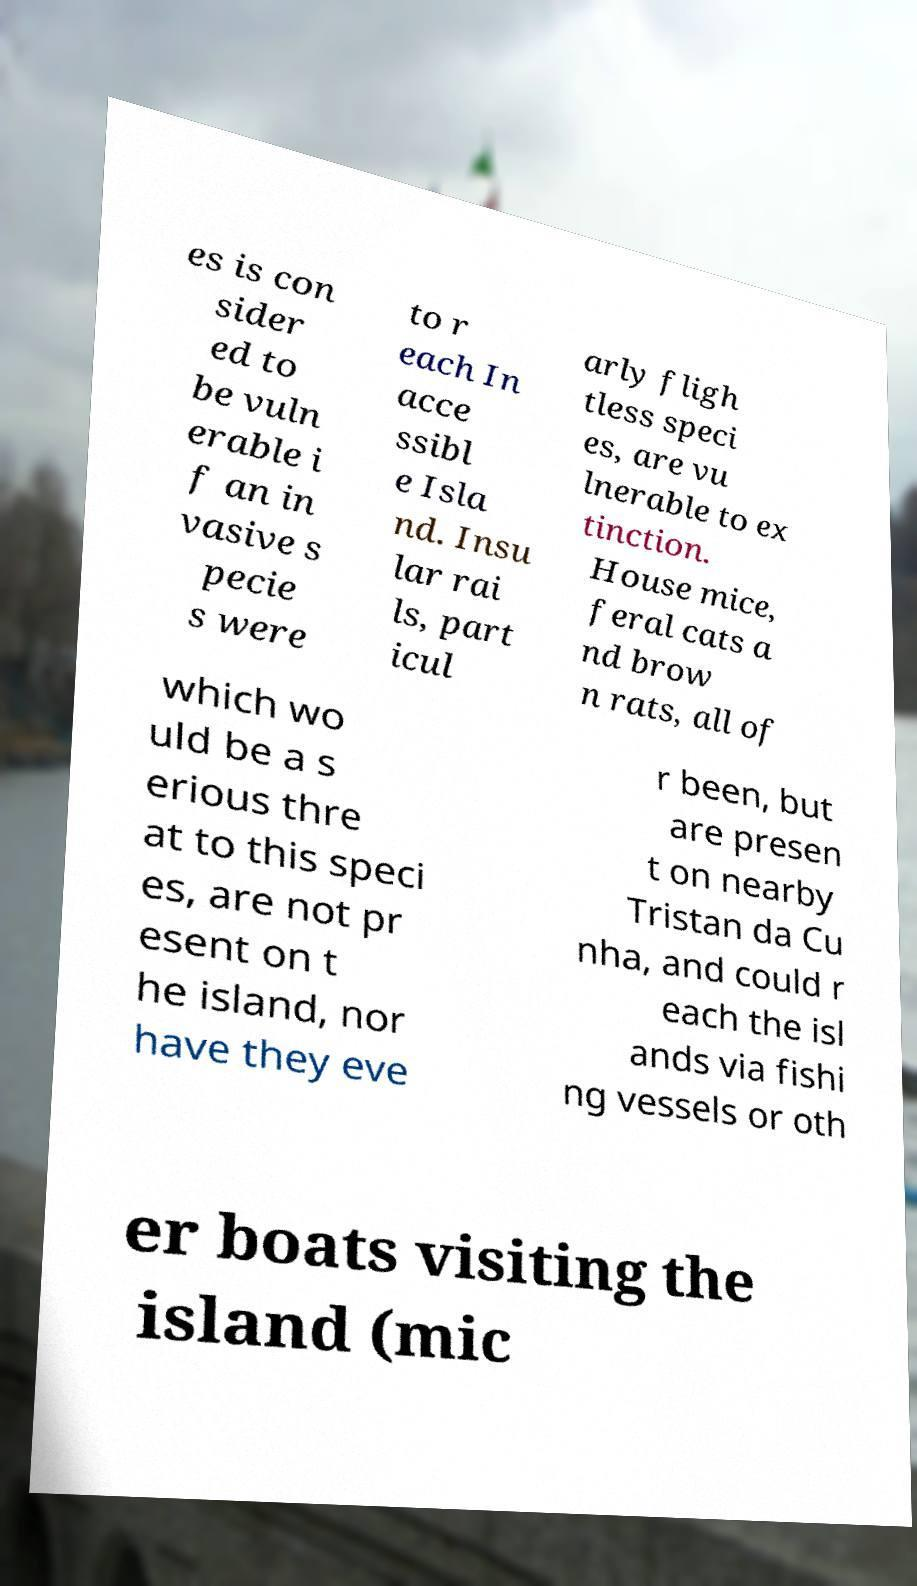Could you extract and type out the text from this image? es is con sider ed to be vuln erable i f an in vasive s pecie s were to r each In acce ssibl e Isla nd. Insu lar rai ls, part icul arly fligh tless speci es, are vu lnerable to ex tinction. House mice, feral cats a nd brow n rats, all of which wo uld be a s erious thre at to this speci es, are not pr esent on t he island, nor have they eve r been, but are presen t on nearby Tristan da Cu nha, and could r each the isl ands via fishi ng vessels or oth er boats visiting the island (mic 